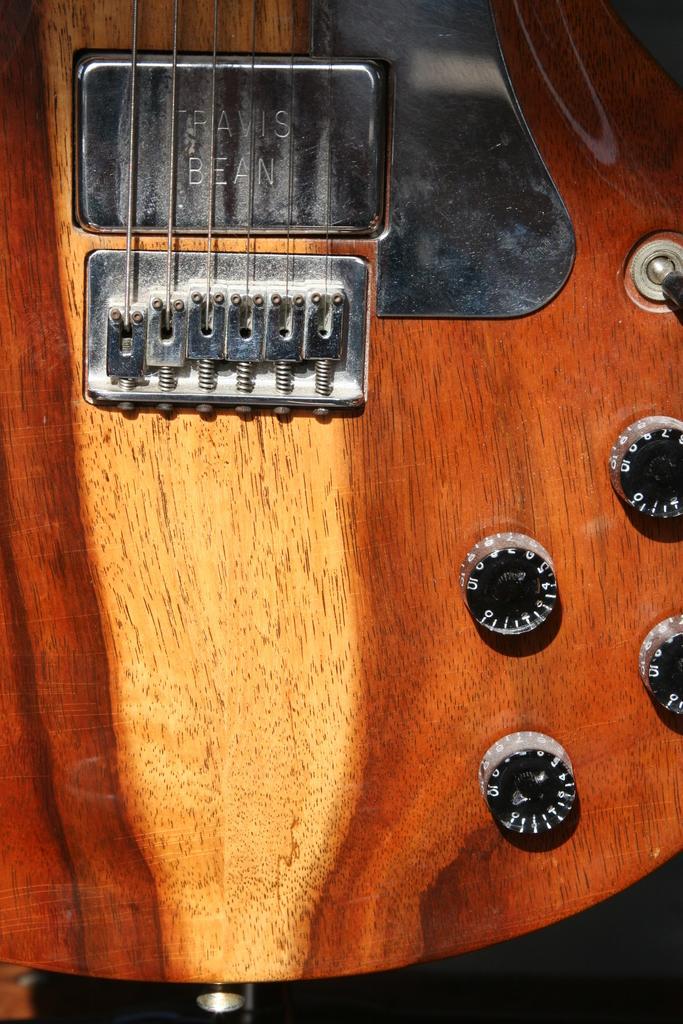In one or two sentences, can you explain what this image depicts? This is a guitar in the given picture with strings and tuners. 